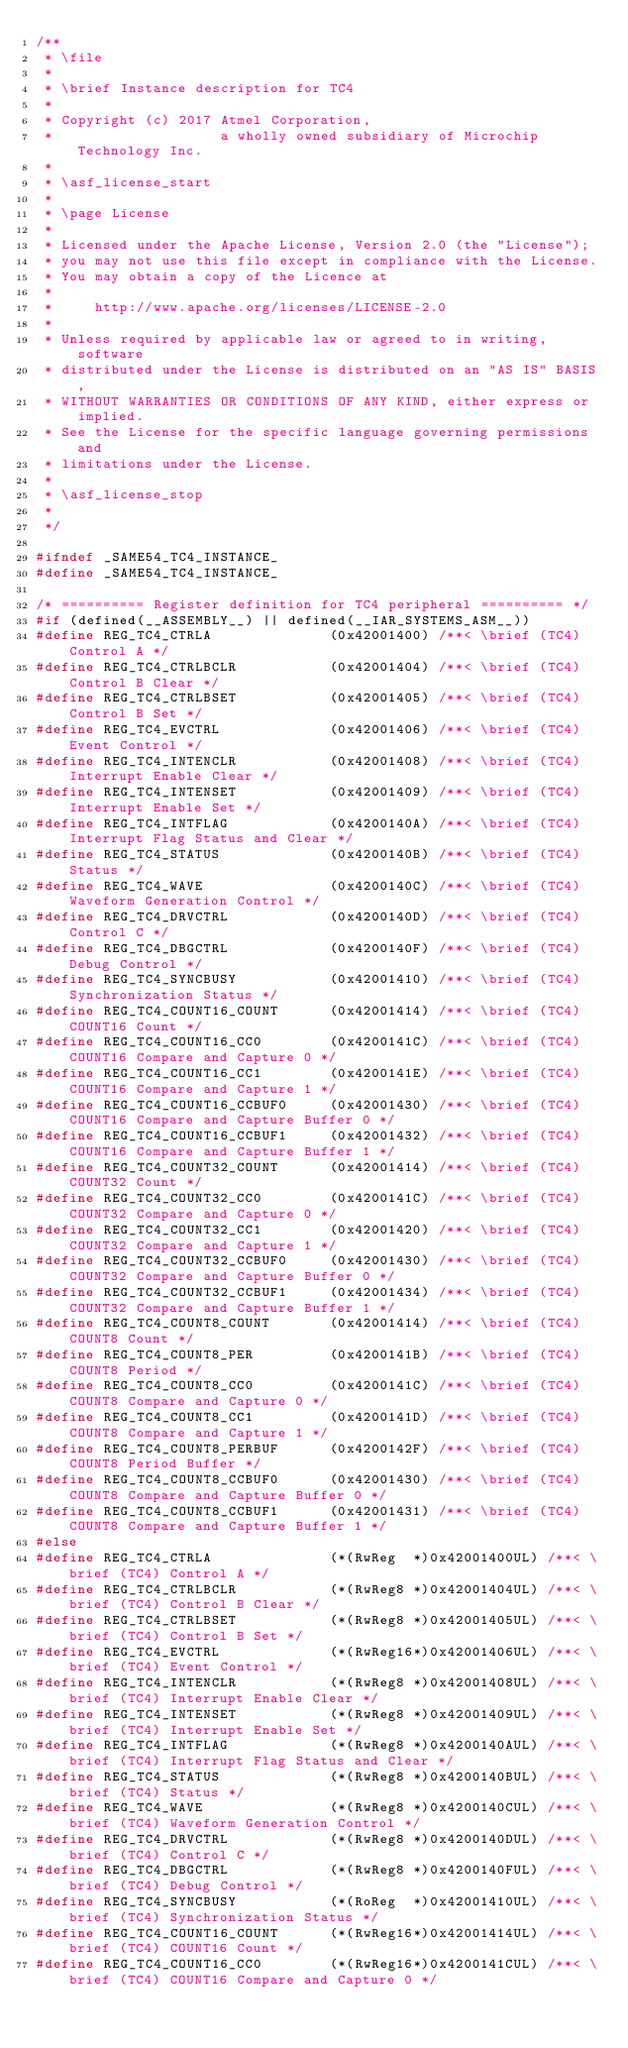<code> <loc_0><loc_0><loc_500><loc_500><_C_>/**
 * \file
 *
 * \brief Instance description for TC4
 *
 * Copyright (c) 2017 Atmel Corporation,
 *                    a wholly owned subsidiary of Microchip Technology Inc.
 *
 * \asf_license_start
 *
 * \page License
 *
 * Licensed under the Apache License, Version 2.0 (the "License");
 * you may not use this file except in compliance with the License.
 * You may obtain a copy of the Licence at
 *
 *     http://www.apache.org/licenses/LICENSE-2.0
 *
 * Unless required by applicable law or agreed to in writing, software
 * distributed under the License is distributed on an "AS IS" BASIS,
 * WITHOUT WARRANTIES OR CONDITIONS OF ANY KIND, either express or implied.
 * See the License for the specific language governing permissions and
 * limitations under the License.
 *
 * \asf_license_stop
 *
 */

#ifndef _SAME54_TC4_INSTANCE_
#define _SAME54_TC4_INSTANCE_

/* ========== Register definition for TC4 peripheral ========== */
#if (defined(__ASSEMBLY__) || defined(__IAR_SYSTEMS_ASM__))
#define REG_TC4_CTRLA              (0x42001400) /**< \brief (TC4) Control A */
#define REG_TC4_CTRLBCLR           (0x42001404) /**< \brief (TC4) Control B Clear */
#define REG_TC4_CTRLBSET           (0x42001405) /**< \brief (TC4) Control B Set */
#define REG_TC4_EVCTRL             (0x42001406) /**< \brief (TC4) Event Control */
#define REG_TC4_INTENCLR           (0x42001408) /**< \brief (TC4) Interrupt Enable Clear */
#define REG_TC4_INTENSET           (0x42001409) /**< \brief (TC4) Interrupt Enable Set */
#define REG_TC4_INTFLAG            (0x4200140A) /**< \brief (TC4) Interrupt Flag Status and Clear */
#define REG_TC4_STATUS             (0x4200140B) /**< \brief (TC4) Status */
#define REG_TC4_WAVE               (0x4200140C) /**< \brief (TC4) Waveform Generation Control */
#define REG_TC4_DRVCTRL            (0x4200140D) /**< \brief (TC4) Control C */
#define REG_TC4_DBGCTRL            (0x4200140F) /**< \brief (TC4) Debug Control */
#define REG_TC4_SYNCBUSY           (0x42001410) /**< \brief (TC4) Synchronization Status */
#define REG_TC4_COUNT16_COUNT      (0x42001414) /**< \brief (TC4) COUNT16 Count */
#define REG_TC4_COUNT16_CC0        (0x4200141C) /**< \brief (TC4) COUNT16 Compare and Capture 0 */
#define REG_TC4_COUNT16_CC1        (0x4200141E) /**< \brief (TC4) COUNT16 Compare and Capture 1 */
#define REG_TC4_COUNT16_CCBUF0     (0x42001430) /**< \brief (TC4) COUNT16 Compare and Capture Buffer 0 */
#define REG_TC4_COUNT16_CCBUF1     (0x42001432) /**< \brief (TC4) COUNT16 Compare and Capture Buffer 1 */
#define REG_TC4_COUNT32_COUNT      (0x42001414) /**< \brief (TC4) COUNT32 Count */
#define REG_TC4_COUNT32_CC0        (0x4200141C) /**< \brief (TC4) COUNT32 Compare and Capture 0 */
#define REG_TC4_COUNT32_CC1        (0x42001420) /**< \brief (TC4) COUNT32 Compare and Capture 1 */
#define REG_TC4_COUNT32_CCBUF0     (0x42001430) /**< \brief (TC4) COUNT32 Compare and Capture Buffer 0 */
#define REG_TC4_COUNT32_CCBUF1     (0x42001434) /**< \brief (TC4) COUNT32 Compare and Capture Buffer 1 */
#define REG_TC4_COUNT8_COUNT       (0x42001414) /**< \brief (TC4) COUNT8 Count */
#define REG_TC4_COUNT8_PER         (0x4200141B) /**< \brief (TC4) COUNT8 Period */
#define REG_TC4_COUNT8_CC0         (0x4200141C) /**< \brief (TC4) COUNT8 Compare and Capture 0 */
#define REG_TC4_COUNT8_CC1         (0x4200141D) /**< \brief (TC4) COUNT8 Compare and Capture 1 */
#define REG_TC4_COUNT8_PERBUF      (0x4200142F) /**< \brief (TC4) COUNT8 Period Buffer */
#define REG_TC4_COUNT8_CCBUF0      (0x42001430) /**< \brief (TC4) COUNT8 Compare and Capture Buffer 0 */
#define REG_TC4_COUNT8_CCBUF1      (0x42001431) /**< \brief (TC4) COUNT8 Compare and Capture Buffer 1 */
#else
#define REG_TC4_CTRLA              (*(RwReg  *)0x42001400UL) /**< \brief (TC4) Control A */
#define REG_TC4_CTRLBCLR           (*(RwReg8 *)0x42001404UL) /**< \brief (TC4) Control B Clear */
#define REG_TC4_CTRLBSET           (*(RwReg8 *)0x42001405UL) /**< \brief (TC4) Control B Set */
#define REG_TC4_EVCTRL             (*(RwReg16*)0x42001406UL) /**< \brief (TC4) Event Control */
#define REG_TC4_INTENCLR           (*(RwReg8 *)0x42001408UL) /**< \brief (TC4) Interrupt Enable Clear */
#define REG_TC4_INTENSET           (*(RwReg8 *)0x42001409UL) /**< \brief (TC4) Interrupt Enable Set */
#define REG_TC4_INTFLAG            (*(RwReg8 *)0x4200140AUL) /**< \brief (TC4) Interrupt Flag Status and Clear */
#define REG_TC4_STATUS             (*(RwReg8 *)0x4200140BUL) /**< \brief (TC4) Status */
#define REG_TC4_WAVE               (*(RwReg8 *)0x4200140CUL) /**< \brief (TC4) Waveform Generation Control */
#define REG_TC4_DRVCTRL            (*(RwReg8 *)0x4200140DUL) /**< \brief (TC4) Control C */
#define REG_TC4_DBGCTRL            (*(RwReg8 *)0x4200140FUL) /**< \brief (TC4) Debug Control */
#define REG_TC4_SYNCBUSY           (*(RoReg  *)0x42001410UL) /**< \brief (TC4) Synchronization Status */
#define REG_TC4_COUNT16_COUNT      (*(RwReg16*)0x42001414UL) /**< \brief (TC4) COUNT16 Count */
#define REG_TC4_COUNT16_CC0        (*(RwReg16*)0x4200141CUL) /**< \brief (TC4) COUNT16 Compare and Capture 0 */</code> 